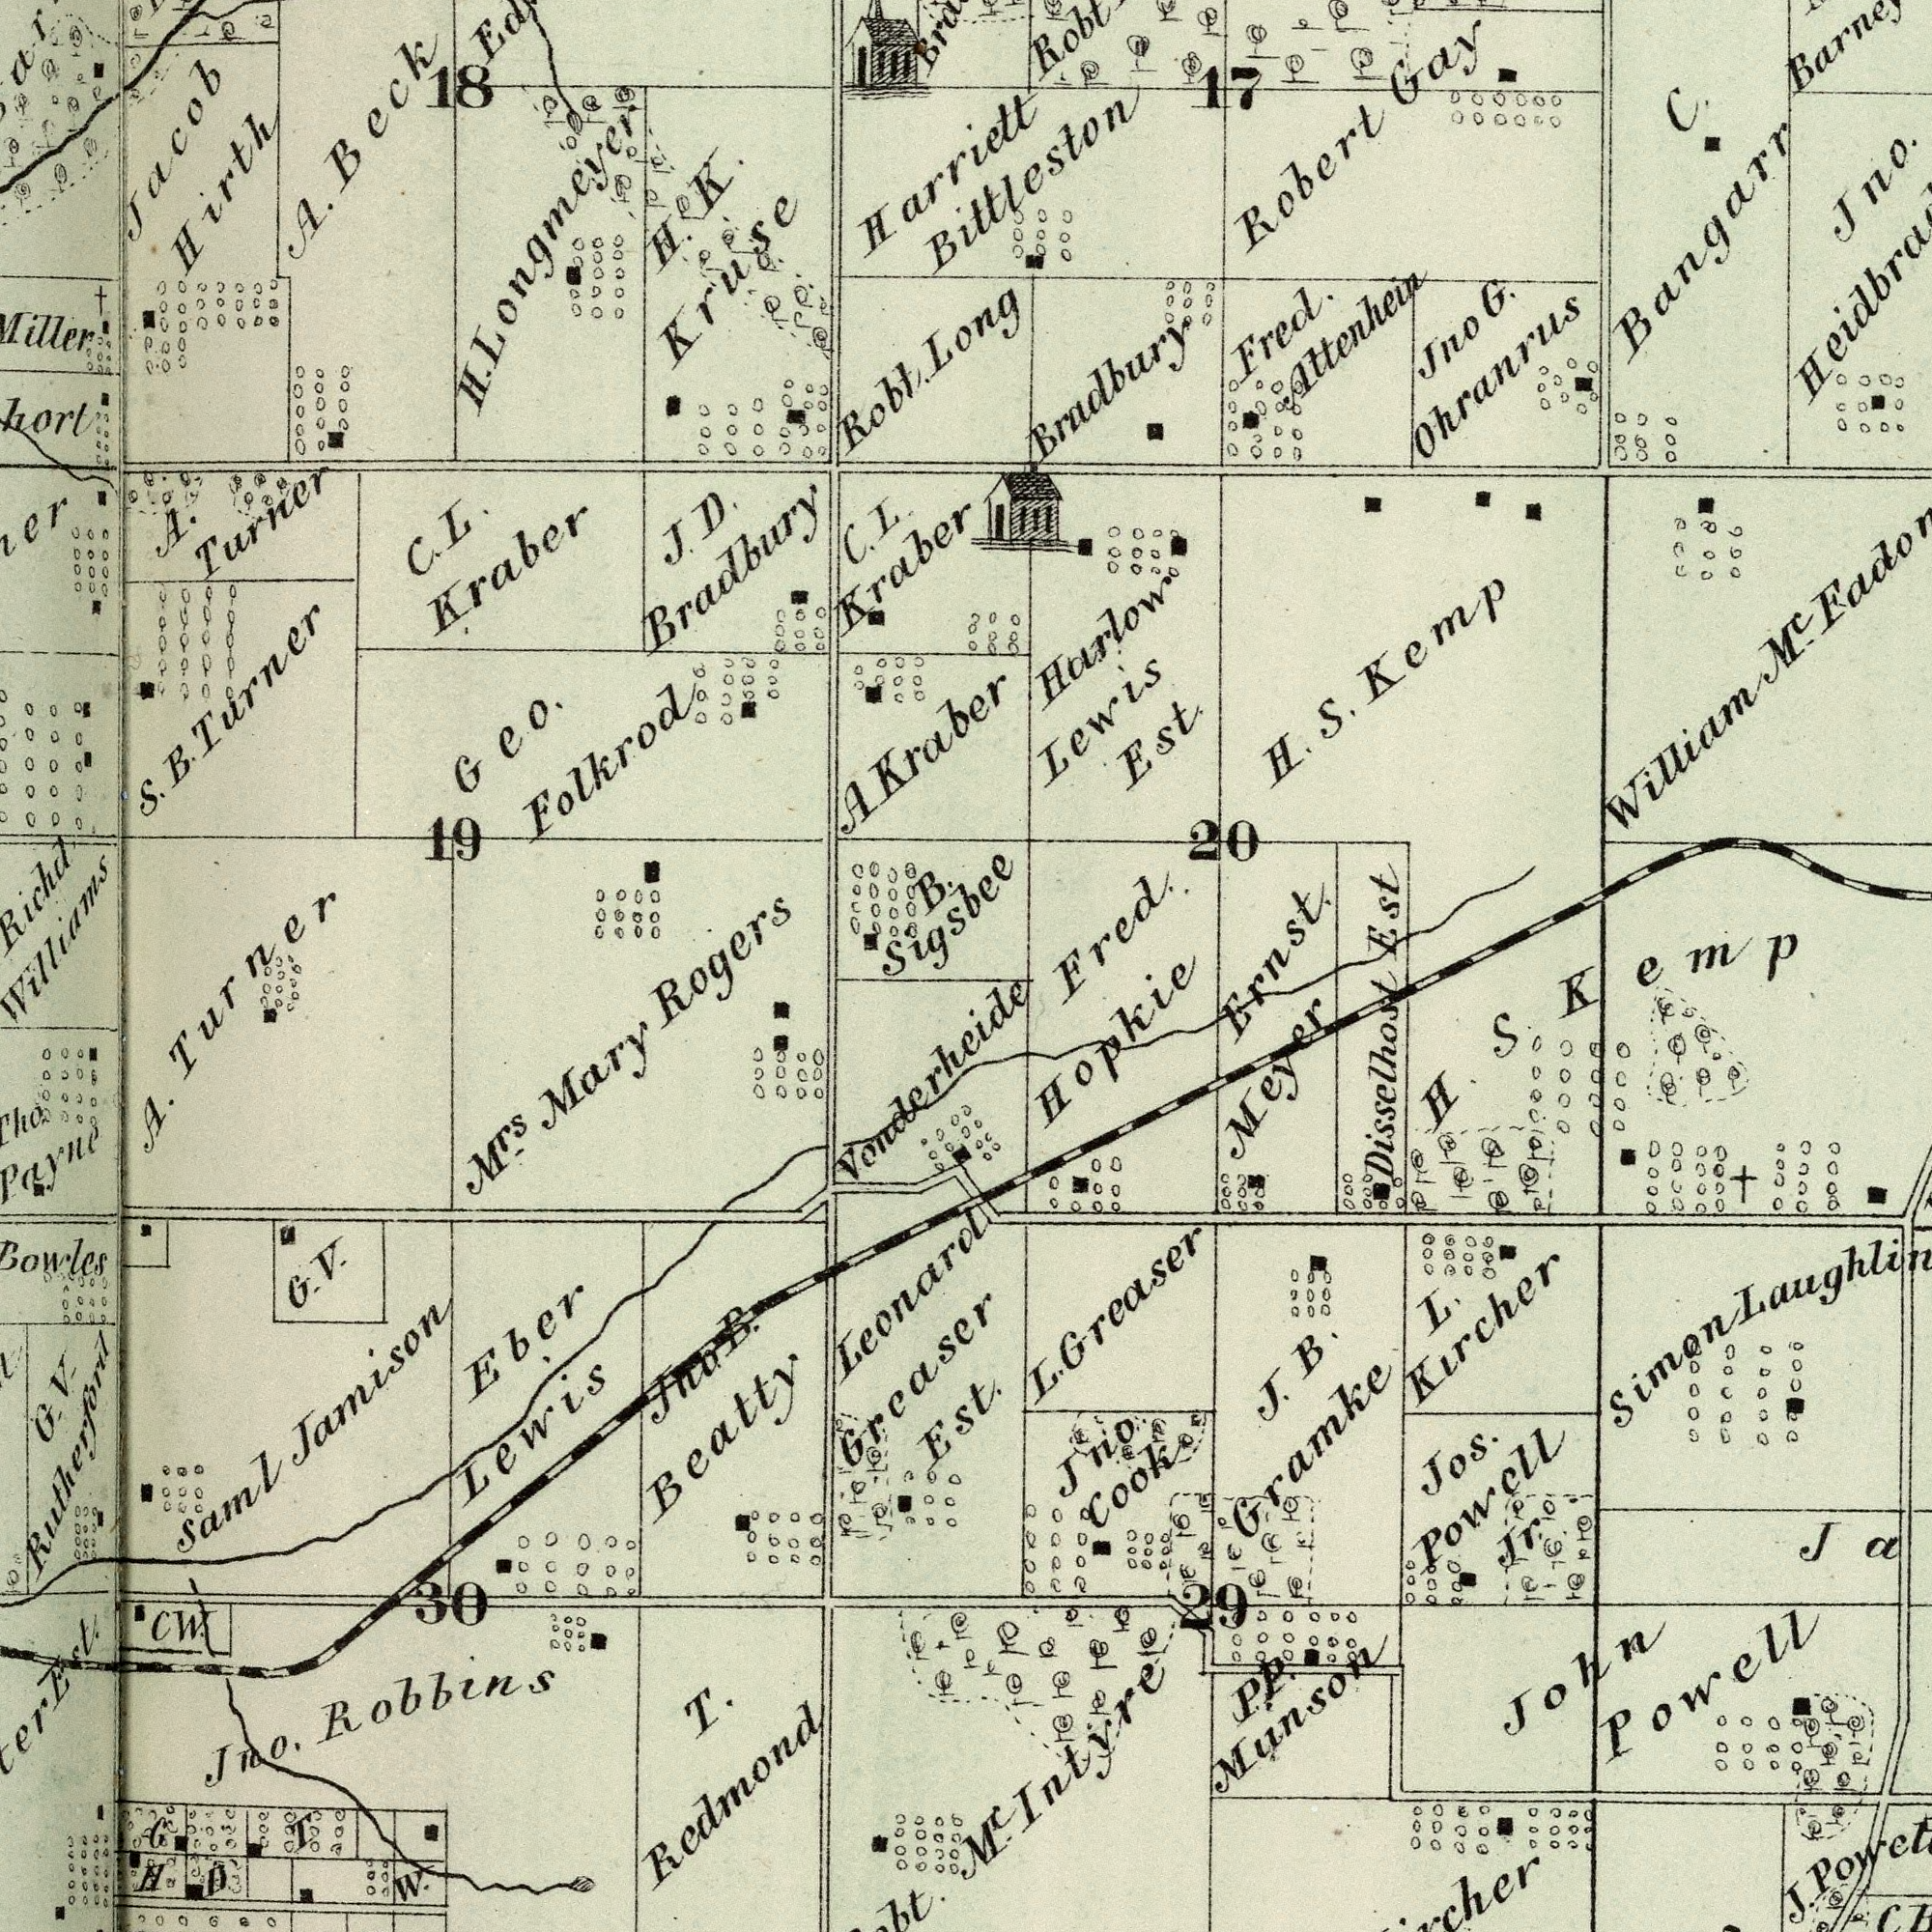What text is visible in the upper-left corner? A. Beck 19 S. B. Turner Geo. Folkrod A. Turner H. K. Kruse Jacob Hirth C. L. Kraber C. L. Kraber Robt. 18 B. Sigsbee A Kraber Harriett Rogers H. Longmeyer J. D. Bradbury What text can you see in the top-right section? Long Jno G. Ohranrus Robert Gay Harlow Lewis Est. Bittleston Est H. S. Kemp Jno. William MC 20 C. Bangarr 17 Fred. Attenhein Bradbury Fred. Ernst What text can you see in the bottom-right section? Disselhost MC Intyre Jos. Powell Jr. L. Kircher P. P. Munson J. L. Greaser John Powell J. B. Gramke Jno. Cook H. S. Kemp Simon Hopkie Meyer 29 What text appears in the bottom-left area of the image? T. Redmond Eber Lewis Jno. Robbins A. Turner CW. Mrs. Mary 30 T H G. V. Saml Jamison W. Vonderheide G. V. Rutherford Jno. B. Beatty Leonard Greaser Est. Est. D G 